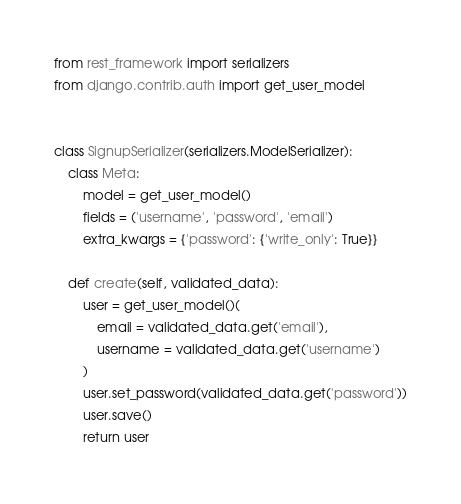<code> <loc_0><loc_0><loc_500><loc_500><_Python_>from rest_framework import serializers
from django.contrib.auth import get_user_model


class SignupSerializer(serializers.ModelSerializer):
    class Meta:
        model = get_user_model()
        fields = ('username', 'password', 'email')
        extra_kwargs = {'password': {'write_only': True}}

    def create(self, validated_data):
        user = get_user_model()(
            email = validated_data.get('email'),
            username = validated_data.get('username')
        )
        user.set_password(validated_data.get('password'))
        user.save()
        return user

</code> 